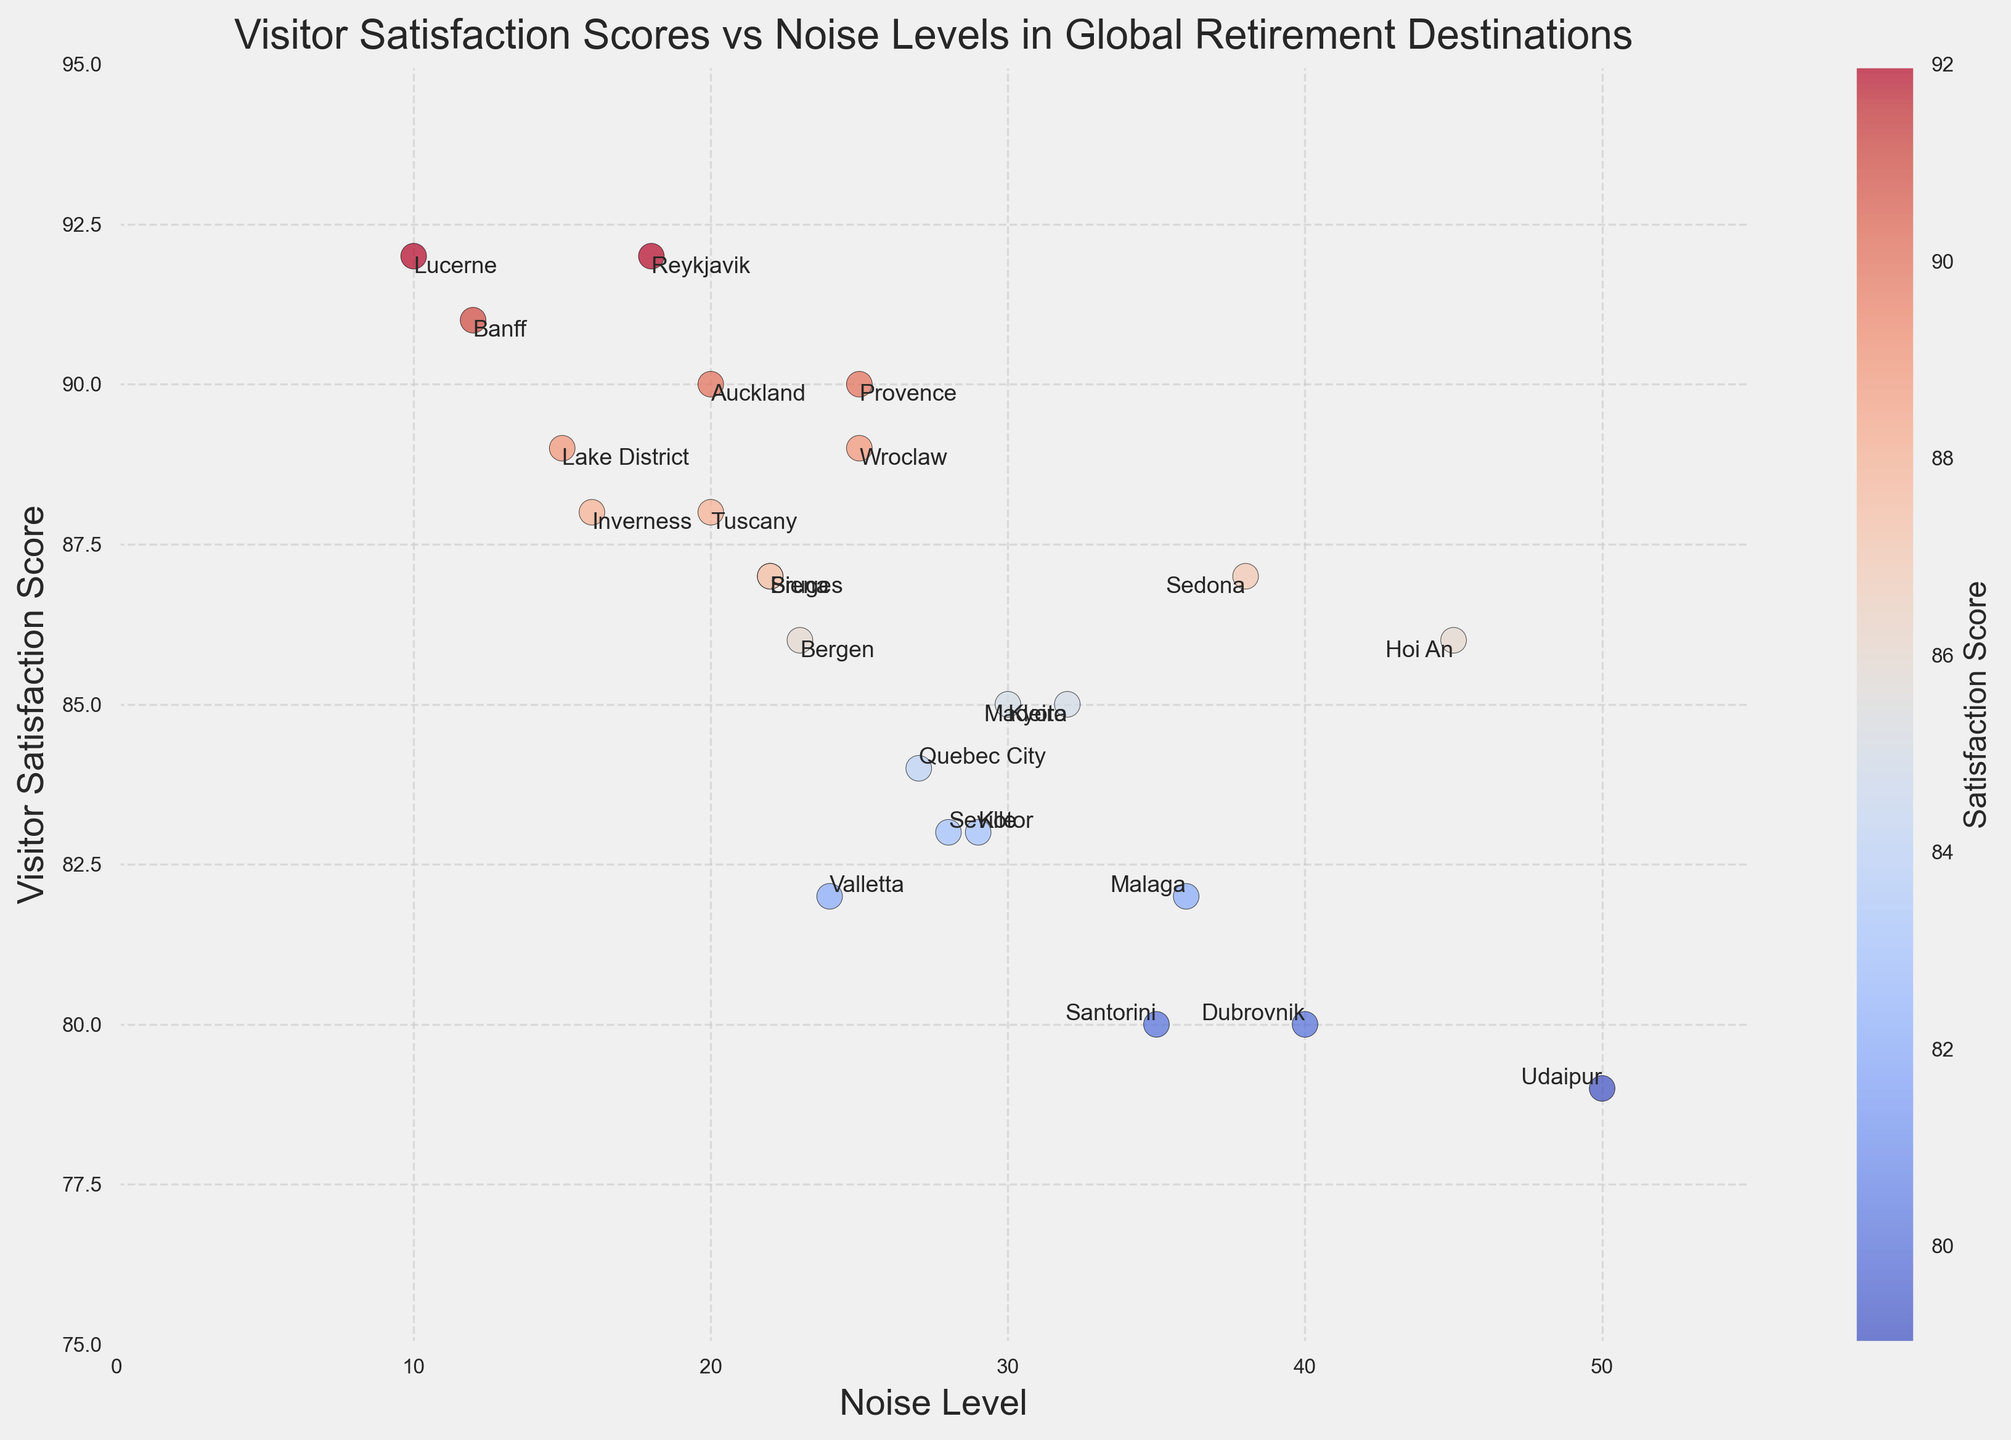What's the most tranquil retirement destination based on the lowest noise level? The most tranquil retirement destination is determined by finding the destination with the lowest noise level from the scatter plot. The destination with the lowest noise level is Banff with a noise level of 12.
Answer: Banff Which destination has the highest visitor satisfaction score, and what is its corresponding noise level? First, identify the destination with the highest satisfaction score from the scatter plot. Reykjavik and Lucerne both have the highest visitor satisfaction score of 92. Then, check their noise levels, which are 18 for Reykjavik and 10 for Lucerne.
Answer: Reykjavik and Lucerne, 18 and 10 Is there a destination with a noise level greater than 40? Examine the scatter plot to identify if there are any points with a noise level above 40. Udaipur has a noise level of 50, which is greater than 40.
Answer: Udaipur What is the range of visitor satisfaction scores for destinations with noise levels below 30? Identify the destinations with noise levels below 30 from the scatter plot. These destinations are Provence, Tuscany, Reykjavik, Bruges, Lake District, Auckland, Lucerne, Inverness, and Wroclaw. Their satisfaction scores range from 85 to 92.
Answer: 85 to 92 Compare the visitor satisfaction scores of Kyoto and Madeira. Which one is higher? Locate the points for Kyoto and Madeira on the scatter plot and compare their satisfaction scores. Kyoto has a score of 85, and Madeira has a score of 85 too.
Answer: Equal Which destination with a noise level above 35 has the highest visitor satisfaction score? Look for destinations on the scatter plot with noise levels above 35. The destinations are Hoi An, Sedona, Malaga, Dubrovnik, and Udaipur. Hoi An and Sedona both have the highest satisfaction score of 87 among them.
Answer: Hoi An and Sedona What's the average satisfaction score for destinations with noise levels between 20 and 30? Determine the destinations with noise levels between 20 and 30, which are Kyoto, Provence, Seville, Bruges, Quebec City, Valletta, Bergen, Wroclaw, Siena, and Kotor. Calculate their average satisfaction score: (85 + 90 + 83 + 87 + 84 + 82 + 86 + 89 + 87 + 83) / 10 = 85.6.
Answer: 85.6 Which destination has a satisfaction score of 80, and what's its noise level? Identify the point(s) in the scatter plot where the satisfaction score is 80. Santorini and Dubrovnik both have a satisfaction score of 80. Their noise levels are 35 and 40, respectively.
Answer: Santorini and Dubrovnik, 35 and 40 